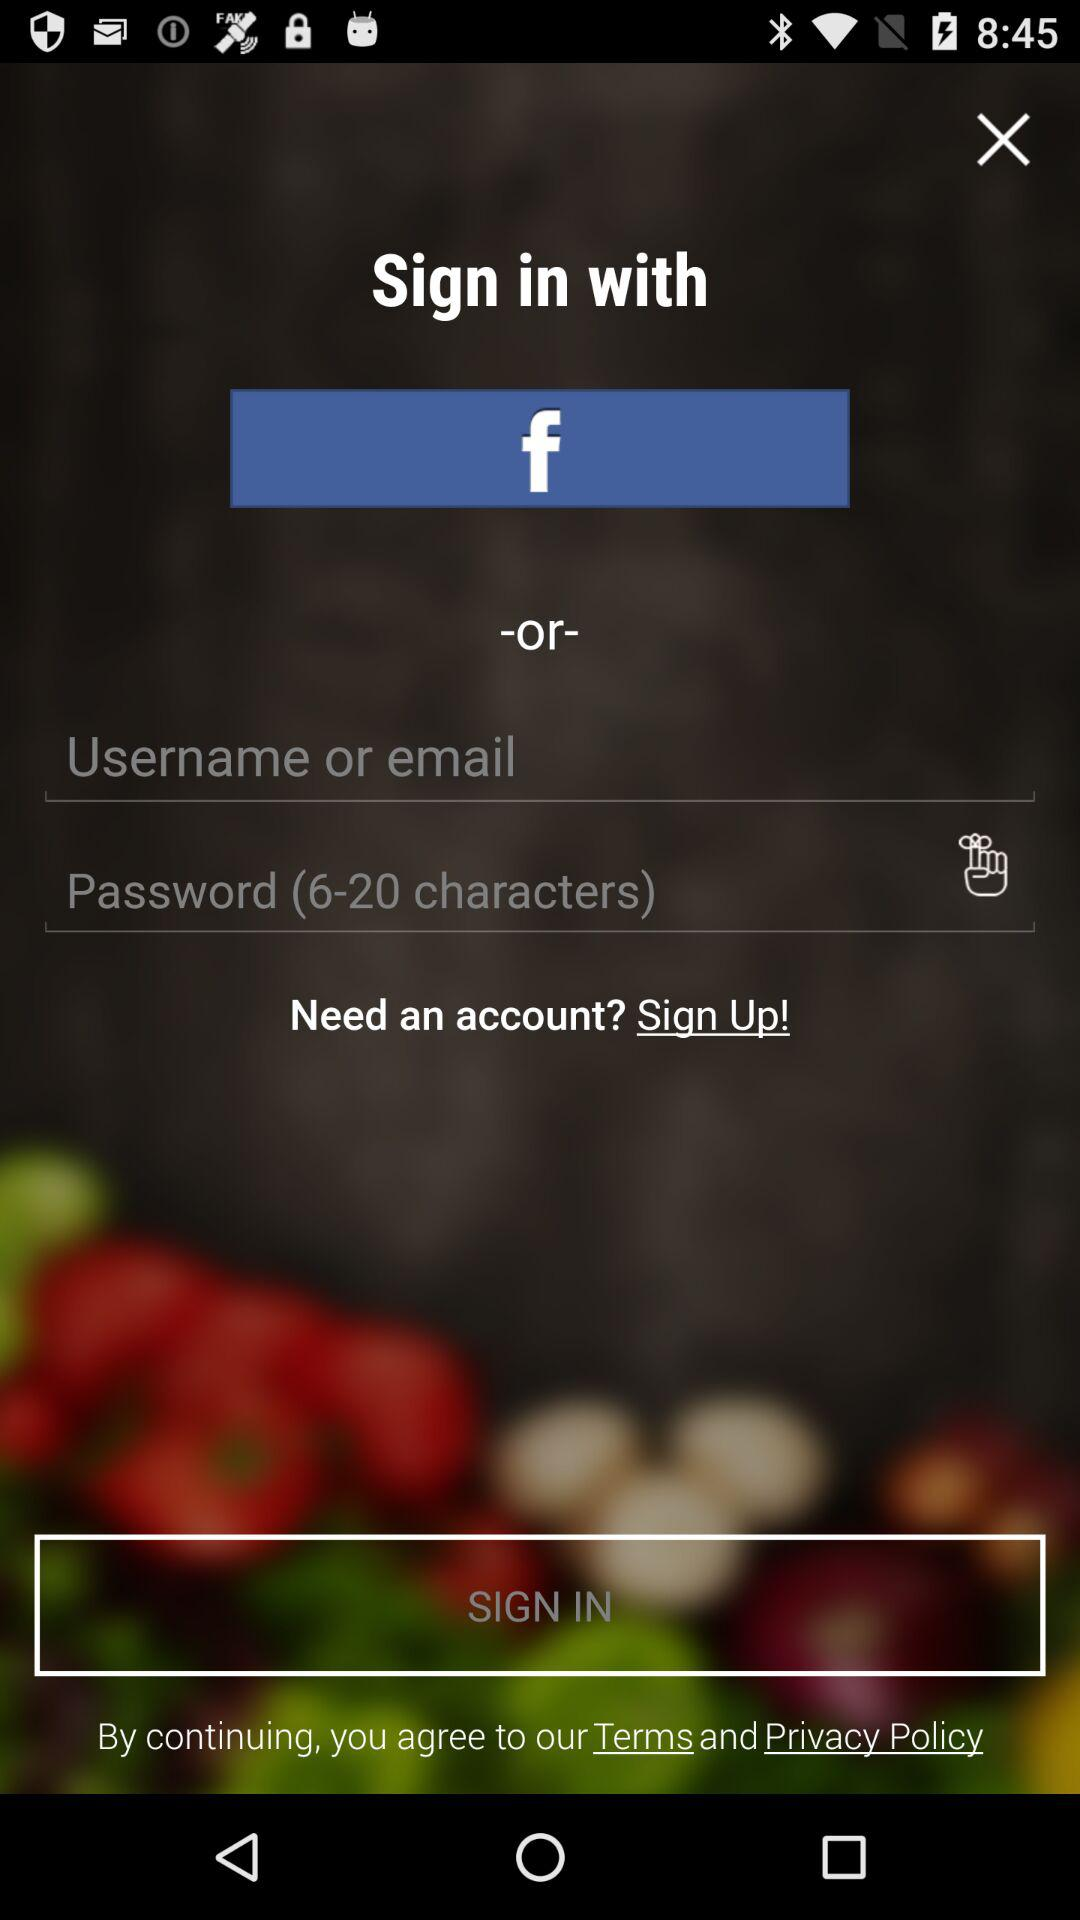How many text input fields are there in total?
Answer the question using a single word or phrase. 2 